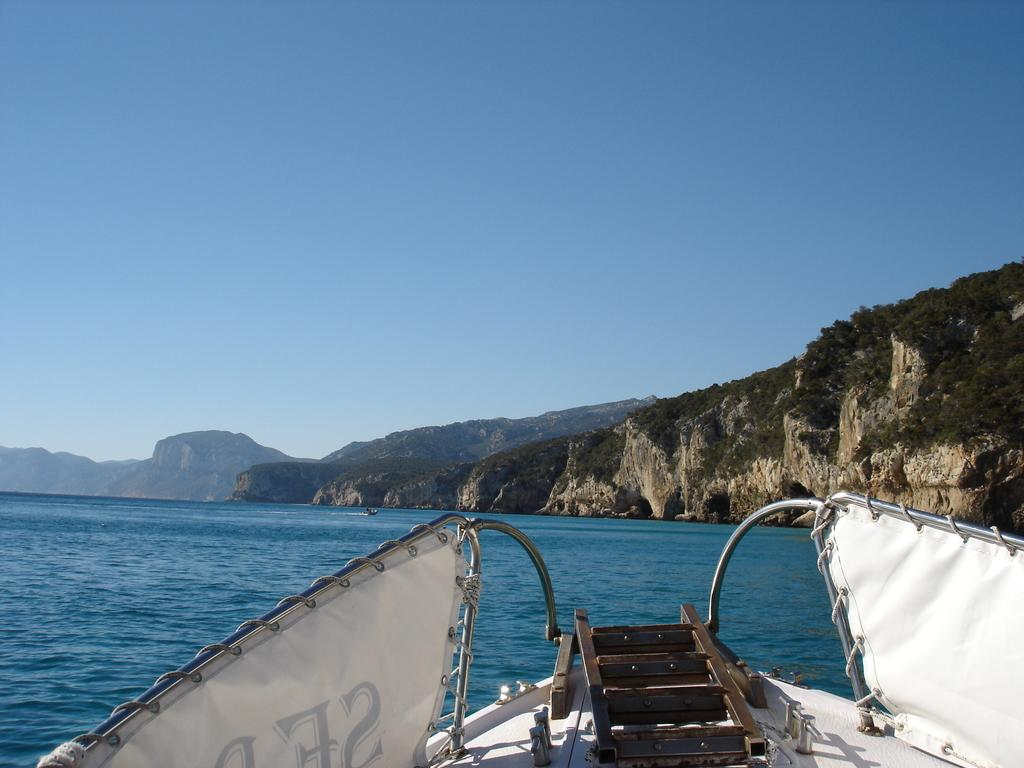What is the main subject of the image? The main subject of the image is a ship. What is the ship doing in the image? The ship is sailing on the water. What can be seen in the background of the image? There are hills and the sky visible in the image. What object is present on the ship? There is an object on the ship. How does the ship feel about the boy playing with money in the image? There is no boy playing with money in the image, and the ship is an inanimate object, so it cannot have feelings. 